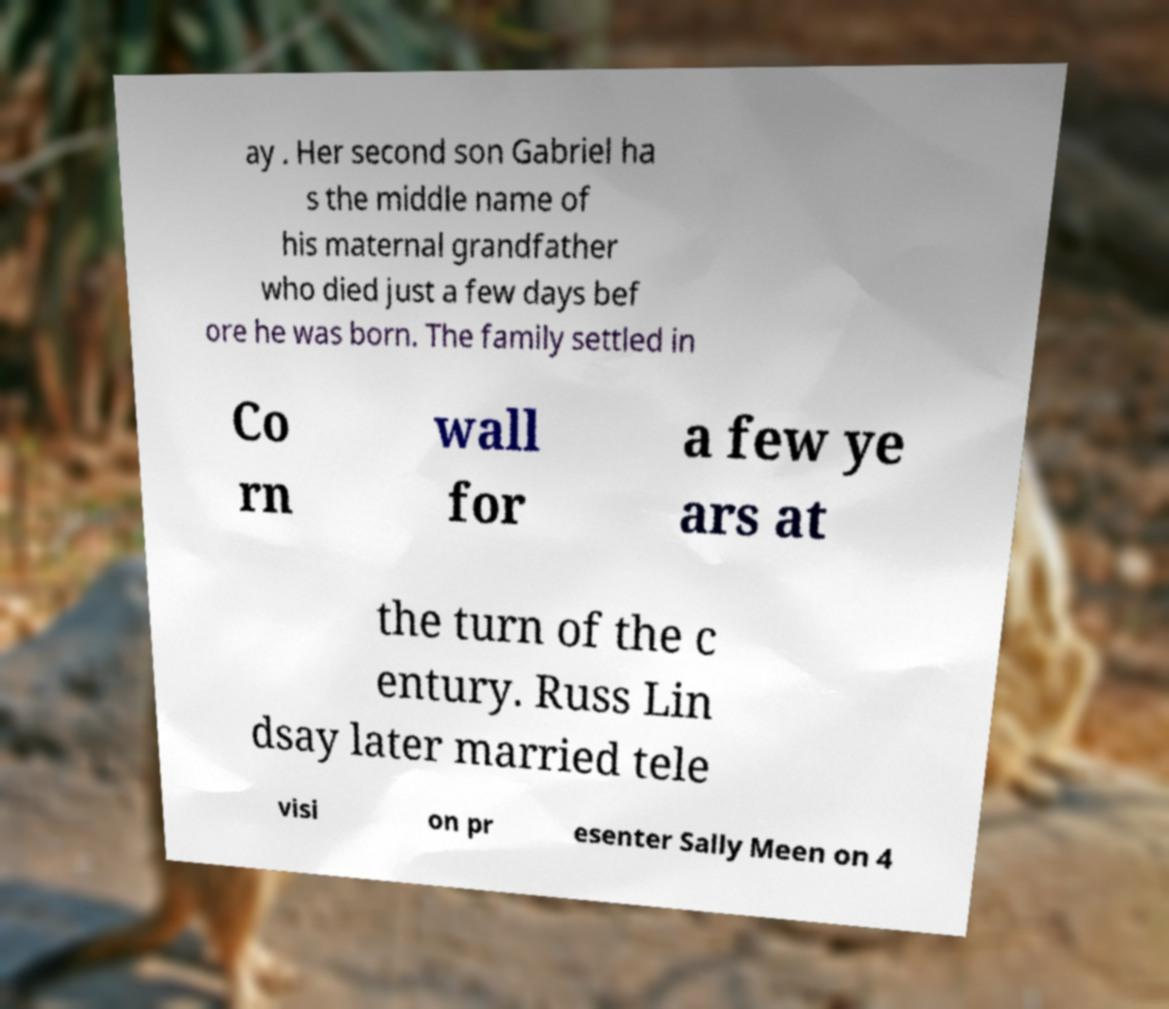Please identify and transcribe the text found in this image. ay . Her second son Gabriel ha s the middle name of his maternal grandfather who died just a few days bef ore he was born. The family settled in Co rn wall for a few ye ars at the turn of the c entury. Russ Lin dsay later married tele visi on pr esenter Sally Meen on 4 